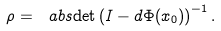<formula> <loc_0><loc_0><loc_500><loc_500>\rho = \ a b s { \det \left ( I - d \Phi ( x _ { 0 } ) \right ) } ^ { - 1 } \, .</formula> 